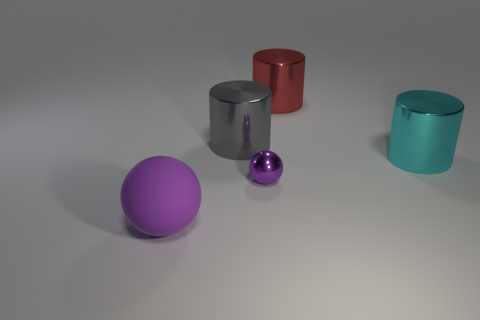The purple metal ball has what size?
Keep it short and to the point. Small. Are there any rubber balls in front of the big gray metallic object behind the large thing that is to the left of the big gray cylinder?
Offer a terse response. Yes. What number of purple spheres are in front of the metallic sphere?
Give a very brief answer. 1. What number of things are the same color as the rubber sphere?
Make the answer very short. 1. How many objects are large things behind the big rubber thing or metallic things that are on the left side of the tiny object?
Keep it short and to the point. 3. Is the number of small shiny things greater than the number of gray matte spheres?
Provide a succinct answer. Yes. There is a big thing that is in front of the small purple object; what is its color?
Provide a succinct answer. Purple. Is the shape of the big cyan thing the same as the large purple thing?
Ensure brevity in your answer.  No. There is a thing that is behind the rubber thing and in front of the cyan cylinder; what is its color?
Offer a very short reply. Purple. Do the gray metal object that is right of the big purple matte object and the metallic object in front of the cyan object have the same size?
Make the answer very short. No. 